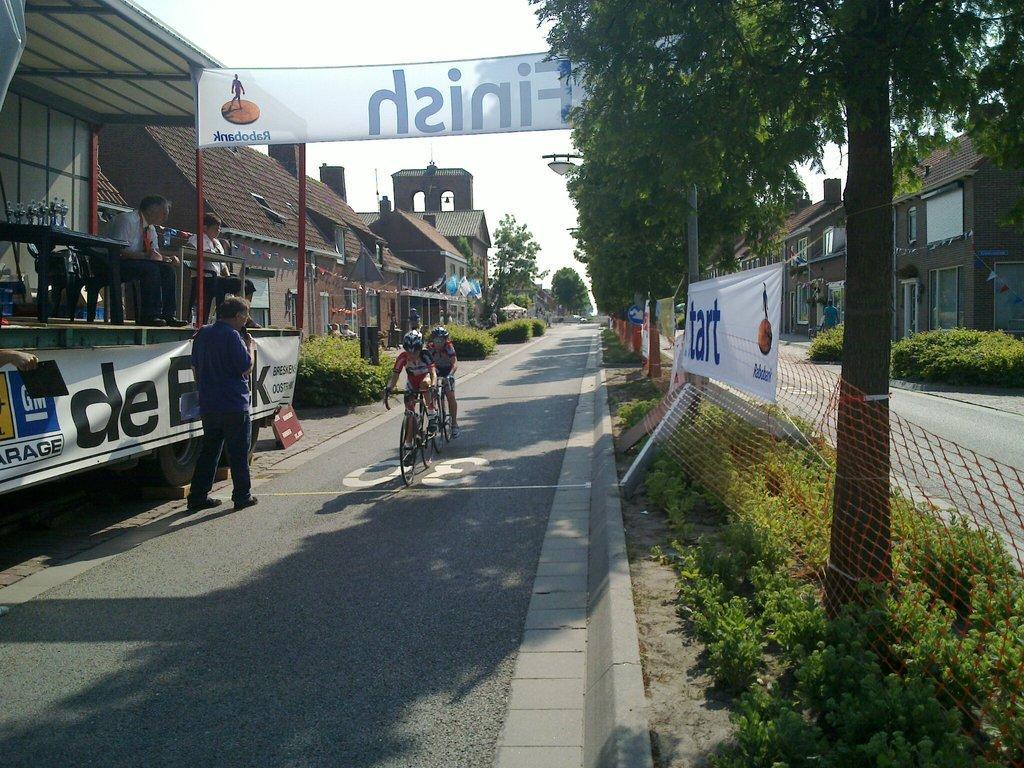How would you summarize this image in a sentence or two? In this picture we can see a man standing, two people are riding bicycles on the road, two men are sitting on chairs, banners, fence, table, plants, buildings, trees, some objects and in the background we can see the sky. 